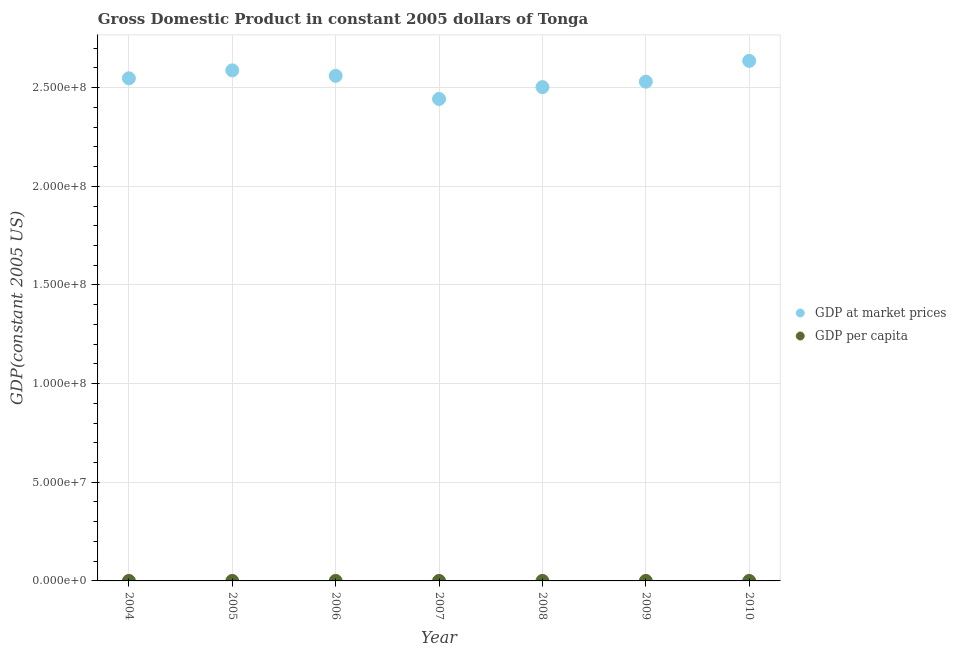Is the number of dotlines equal to the number of legend labels?
Offer a terse response. Yes. What is the gdp at market prices in 2006?
Give a very brief answer. 2.56e+08. Across all years, what is the maximum gdp at market prices?
Give a very brief answer. 2.64e+08. Across all years, what is the minimum gdp per capita?
Keep it short and to the point. 2390.7. In which year was the gdp per capita minimum?
Keep it short and to the point. 2007. What is the total gdp at market prices in the graph?
Your answer should be compact. 1.78e+09. What is the difference between the gdp at market prices in 2006 and that in 2008?
Your answer should be compact. 5.70e+06. What is the difference between the gdp per capita in 2010 and the gdp at market prices in 2004?
Offer a terse response. -2.55e+08. What is the average gdp at market prices per year?
Ensure brevity in your answer.  2.54e+08. In the year 2010, what is the difference between the gdp at market prices and gdp per capita?
Ensure brevity in your answer.  2.64e+08. In how many years, is the gdp per capita greater than 10000000 US$?
Your response must be concise. 0. What is the ratio of the gdp at market prices in 2006 to that in 2007?
Your response must be concise. 1.05. Is the difference between the gdp at market prices in 2005 and 2009 greater than the difference between the gdp per capita in 2005 and 2009?
Offer a very short reply. Yes. What is the difference between the highest and the second highest gdp per capita?
Provide a succinct answer. 23.91. What is the difference between the highest and the lowest gdp at market prices?
Provide a succinct answer. 1.93e+07. Is the gdp per capita strictly less than the gdp at market prices over the years?
Give a very brief answer. Yes. How many dotlines are there?
Ensure brevity in your answer.  2. How many years are there in the graph?
Ensure brevity in your answer.  7. What is the difference between two consecutive major ticks on the Y-axis?
Provide a succinct answer. 5.00e+07. Does the graph contain grids?
Your answer should be compact. Yes. Where does the legend appear in the graph?
Give a very brief answer. Center right. How are the legend labels stacked?
Offer a very short reply. Vertical. What is the title of the graph?
Make the answer very short. Gross Domestic Product in constant 2005 dollars of Tonga. What is the label or title of the X-axis?
Offer a terse response. Year. What is the label or title of the Y-axis?
Offer a terse response. GDP(constant 2005 US). What is the GDP(constant 2005 US) of GDP at market prices in 2004?
Provide a short and direct response. 2.55e+08. What is the GDP(constant 2005 US) in GDP per capita in 2004?
Make the answer very short. 2541.48. What is the GDP(constant 2005 US) in GDP at market prices in 2005?
Make the answer very short. 2.59e+08. What is the GDP(constant 2005 US) of GDP per capita in 2005?
Your response must be concise. 2565.39. What is the GDP(constant 2005 US) in GDP at market prices in 2006?
Offer a terse response. 2.56e+08. What is the GDP(constant 2005 US) in GDP per capita in 2006?
Your answer should be very brief. 2521.56. What is the GDP(constant 2005 US) in GDP at market prices in 2007?
Make the answer very short. 2.44e+08. What is the GDP(constant 2005 US) in GDP per capita in 2007?
Keep it short and to the point. 2390.7. What is the GDP(constant 2005 US) of GDP at market prices in 2008?
Give a very brief answer. 2.50e+08. What is the GDP(constant 2005 US) in GDP per capita in 2008?
Your response must be concise. 2434.01. What is the GDP(constant 2005 US) in GDP at market prices in 2009?
Keep it short and to the point. 2.53e+08. What is the GDP(constant 2005 US) of GDP per capita in 2009?
Ensure brevity in your answer.  2446.5. What is the GDP(constant 2005 US) in GDP at market prices in 2010?
Make the answer very short. 2.64e+08. What is the GDP(constant 2005 US) in GDP per capita in 2010?
Your answer should be compact. 2535.39. Across all years, what is the maximum GDP(constant 2005 US) in GDP at market prices?
Your answer should be very brief. 2.64e+08. Across all years, what is the maximum GDP(constant 2005 US) in GDP per capita?
Offer a terse response. 2565.39. Across all years, what is the minimum GDP(constant 2005 US) of GDP at market prices?
Ensure brevity in your answer.  2.44e+08. Across all years, what is the minimum GDP(constant 2005 US) of GDP per capita?
Offer a terse response. 2390.7. What is the total GDP(constant 2005 US) of GDP at market prices in the graph?
Your response must be concise. 1.78e+09. What is the total GDP(constant 2005 US) in GDP per capita in the graph?
Offer a very short reply. 1.74e+04. What is the difference between the GDP(constant 2005 US) in GDP at market prices in 2004 and that in 2005?
Make the answer very short. -4.02e+06. What is the difference between the GDP(constant 2005 US) of GDP per capita in 2004 and that in 2005?
Make the answer very short. -23.91. What is the difference between the GDP(constant 2005 US) in GDP at market prices in 2004 and that in 2006?
Your answer should be compact. -1.23e+06. What is the difference between the GDP(constant 2005 US) of GDP per capita in 2004 and that in 2006?
Your answer should be very brief. 19.92. What is the difference between the GDP(constant 2005 US) of GDP at market prices in 2004 and that in 2007?
Your answer should be compact. 1.05e+07. What is the difference between the GDP(constant 2005 US) of GDP per capita in 2004 and that in 2007?
Your response must be concise. 150.78. What is the difference between the GDP(constant 2005 US) in GDP at market prices in 2004 and that in 2008?
Offer a very short reply. 4.47e+06. What is the difference between the GDP(constant 2005 US) in GDP per capita in 2004 and that in 2008?
Ensure brevity in your answer.  107.47. What is the difference between the GDP(constant 2005 US) in GDP at market prices in 2004 and that in 2009?
Offer a very short reply. 1.72e+06. What is the difference between the GDP(constant 2005 US) of GDP per capita in 2004 and that in 2009?
Give a very brief answer. 94.98. What is the difference between the GDP(constant 2005 US) of GDP at market prices in 2004 and that in 2010?
Offer a terse response. -8.82e+06. What is the difference between the GDP(constant 2005 US) of GDP per capita in 2004 and that in 2010?
Your response must be concise. 6.09. What is the difference between the GDP(constant 2005 US) of GDP at market prices in 2005 and that in 2006?
Provide a succinct answer. 2.78e+06. What is the difference between the GDP(constant 2005 US) of GDP per capita in 2005 and that in 2006?
Provide a succinct answer. 43.83. What is the difference between the GDP(constant 2005 US) in GDP at market prices in 2005 and that in 2007?
Make the answer very short. 1.45e+07. What is the difference between the GDP(constant 2005 US) in GDP per capita in 2005 and that in 2007?
Keep it short and to the point. 174.68. What is the difference between the GDP(constant 2005 US) in GDP at market prices in 2005 and that in 2008?
Your answer should be very brief. 8.48e+06. What is the difference between the GDP(constant 2005 US) in GDP per capita in 2005 and that in 2008?
Keep it short and to the point. 131.38. What is the difference between the GDP(constant 2005 US) of GDP at market prices in 2005 and that in 2009?
Offer a very short reply. 5.73e+06. What is the difference between the GDP(constant 2005 US) in GDP per capita in 2005 and that in 2009?
Offer a very short reply. 118.89. What is the difference between the GDP(constant 2005 US) of GDP at market prices in 2005 and that in 2010?
Your answer should be very brief. -4.81e+06. What is the difference between the GDP(constant 2005 US) in GDP per capita in 2005 and that in 2010?
Provide a short and direct response. 29.99. What is the difference between the GDP(constant 2005 US) of GDP at market prices in 2006 and that in 2007?
Your answer should be very brief. 1.17e+07. What is the difference between the GDP(constant 2005 US) in GDP per capita in 2006 and that in 2007?
Offer a terse response. 130.85. What is the difference between the GDP(constant 2005 US) of GDP at market prices in 2006 and that in 2008?
Keep it short and to the point. 5.70e+06. What is the difference between the GDP(constant 2005 US) in GDP per capita in 2006 and that in 2008?
Keep it short and to the point. 87.55. What is the difference between the GDP(constant 2005 US) of GDP at market prices in 2006 and that in 2009?
Make the answer very short. 2.95e+06. What is the difference between the GDP(constant 2005 US) in GDP per capita in 2006 and that in 2009?
Ensure brevity in your answer.  75.06. What is the difference between the GDP(constant 2005 US) of GDP at market prices in 2006 and that in 2010?
Ensure brevity in your answer.  -7.59e+06. What is the difference between the GDP(constant 2005 US) of GDP per capita in 2006 and that in 2010?
Give a very brief answer. -13.84. What is the difference between the GDP(constant 2005 US) of GDP at market prices in 2007 and that in 2008?
Offer a very short reply. -6.00e+06. What is the difference between the GDP(constant 2005 US) in GDP per capita in 2007 and that in 2008?
Provide a short and direct response. -43.31. What is the difference between the GDP(constant 2005 US) in GDP at market prices in 2007 and that in 2009?
Give a very brief answer. -8.75e+06. What is the difference between the GDP(constant 2005 US) of GDP per capita in 2007 and that in 2009?
Provide a succinct answer. -55.79. What is the difference between the GDP(constant 2005 US) in GDP at market prices in 2007 and that in 2010?
Provide a short and direct response. -1.93e+07. What is the difference between the GDP(constant 2005 US) in GDP per capita in 2007 and that in 2010?
Make the answer very short. -144.69. What is the difference between the GDP(constant 2005 US) in GDP at market prices in 2008 and that in 2009?
Your response must be concise. -2.75e+06. What is the difference between the GDP(constant 2005 US) in GDP per capita in 2008 and that in 2009?
Your answer should be very brief. -12.49. What is the difference between the GDP(constant 2005 US) in GDP at market prices in 2008 and that in 2010?
Offer a terse response. -1.33e+07. What is the difference between the GDP(constant 2005 US) of GDP per capita in 2008 and that in 2010?
Your answer should be very brief. -101.38. What is the difference between the GDP(constant 2005 US) in GDP at market prices in 2009 and that in 2010?
Your response must be concise. -1.05e+07. What is the difference between the GDP(constant 2005 US) in GDP per capita in 2009 and that in 2010?
Offer a terse response. -88.9. What is the difference between the GDP(constant 2005 US) in GDP at market prices in 2004 and the GDP(constant 2005 US) in GDP per capita in 2005?
Offer a terse response. 2.55e+08. What is the difference between the GDP(constant 2005 US) in GDP at market prices in 2004 and the GDP(constant 2005 US) in GDP per capita in 2006?
Your answer should be compact. 2.55e+08. What is the difference between the GDP(constant 2005 US) in GDP at market prices in 2004 and the GDP(constant 2005 US) in GDP per capita in 2007?
Provide a succinct answer. 2.55e+08. What is the difference between the GDP(constant 2005 US) in GDP at market prices in 2004 and the GDP(constant 2005 US) in GDP per capita in 2008?
Your response must be concise. 2.55e+08. What is the difference between the GDP(constant 2005 US) of GDP at market prices in 2004 and the GDP(constant 2005 US) of GDP per capita in 2009?
Offer a terse response. 2.55e+08. What is the difference between the GDP(constant 2005 US) in GDP at market prices in 2004 and the GDP(constant 2005 US) in GDP per capita in 2010?
Your answer should be compact. 2.55e+08. What is the difference between the GDP(constant 2005 US) of GDP at market prices in 2005 and the GDP(constant 2005 US) of GDP per capita in 2006?
Your answer should be very brief. 2.59e+08. What is the difference between the GDP(constant 2005 US) of GDP at market prices in 2005 and the GDP(constant 2005 US) of GDP per capita in 2007?
Offer a very short reply. 2.59e+08. What is the difference between the GDP(constant 2005 US) in GDP at market prices in 2005 and the GDP(constant 2005 US) in GDP per capita in 2008?
Make the answer very short. 2.59e+08. What is the difference between the GDP(constant 2005 US) of GDP at market prices in 2005 and the GDP(constant 2005 US) of GDP per capita in 2009?
Offer a very short reply. 2.59e+08. What is the difference between the GDP(constant 2005 US) of GDP at market prices in 2005 and the GDP(constant 2005 US) of GDP per capita in 2010?
Ensure brevity in your answer.  2.59e+08. What is the difference between the GDP(constant 2005 US) of GDP at market prices in 2006 and the GDP(constant 2005 US) of GDP per capita in 2007?
Ensure brevity in your answer.  2.56e+08. What is the difference between the GDP(constant 2005 US) of GDP at market prices in 2006 and the GDP(constant 2005 US) of GDP per capita in 2008?
Make the answer very short. 2.56e+08. What is the difference between the GDP(constant 2005 US) of GDP at market prices in 2006 and the GDP(constant 2005 US) of GDP per capita in 2009?
Provide a short and direct response. 2.56e+08. What is the difference between the GDP(constant 2005 US) of GDP at market prices in 2006 and the GDP(constant 2005 US) of GDP per capita in 2010?
Your answer should be very brief. 2.56e+08. What is the difference between the GDP(constant 2005 US) of GDP at market prices in 2007 and the GDP(constant 2005 US) of GDP per capita in 2008?
Your answer should be very brief. 2.44e+08. What is the difference between the GDP(constant 2005 US) in GDP at market prices in 2007 and the GDP(constant 2005 US) in GDP per capita in 2009?
Your answer should be very brief. 2.44e+08. What is the difference between the GDP(constant 2005 US) of GDP at market prices in 2007 and the GDP(constant 2005 US) of GDP per capita in 2010?
Provide a short and direct response. 2.44e+08. What is the difference between the GDP(constant 2005 US) in GDP at market prices in 2008 and the GDP(constant 2005 US) in GDP per capita in 2009?
Your response must be concise. 2.50e+08. What is the difference between the GDP(constant 2005 US) in GDP at market prices in 2008 and the GDP(constant 2005 US) in GDP per capita in 2010?
Your response must be concise. 2.50e+08. What is the difference between the GDP(constant 2005 US) of GDP at market prices in 2009 and the GDP(constant 2005 US) of GDP per capita in 2010?
Your answer should be compact. 2.53e+08. What is the average GDP(constant 2005 US) of GDP at market prices per year?
Your answer should be compact. 2.54e+08. What is the average GDP(constant 2005 US) of GDP per capita per year?
Provide a succinct answer. 2490.72. In the year 2004, what is the difference between the GDP(constant 2005 US) of GDP at market prices and GDP(constant 2005 US) of GDP per capita?
Offer a very short reply. 2.55e+08. In the year 2005, what is the difference between the GDP(constant 2005 US) in GDP at market prices and GDP(constant 2005 US) in GDP per capita?
Your answer should be very brief. 2.59e+08. In the year 2006, what is the difference between the GDP(constant 2005 US) in GDP at market prices and GDP(constant 2005 US) in GDP per capita?
Make the answer very short. 2.56e+08. In the year 2007, what is the difference between the GDP(constant 2005 US) in GDP at market prices and GDP(constant 2005 US) in GDP per capita?
Your answer should be very brief. 2.44e+08. In the year 2008, what is the difference between the GDP(constant 2005 US) in GDP at market prices and GDP(constant 2005 US) in GDP per capita?
Provide a succinct answer. 2.50e+08. In the year 2009, what is the difference between the GDP(constant 2005 US) in GDP at market prices and GDP(constant 2005 US) in GDP per capita?
Provide a short and direct response. 2.53e+08. In the year 2010, what is the difference between the GDP(constant 2005 US) of GDP at market prices and GDP(constant 2005 US) of GDP per capita?
Offer a terse response. 2.64e+08. What is the ratio of the GDP(constant 2005 US) of GDP at market prices in 2004 to that in 2005?
Keep it short and to the point. 0.98. What is the ratio of the GDP(constant 2005 US) of GDP per capita in 2004 to that in 2005?
Offer a terse response. 0.99. What is the ratio of the GDP(constant 2005 US) of GDP per capita in 2004 to that in 2006?
Offer a very short reply. 1.01. What is the ratio of the GDP(constant 2005 US) in GDP at market prices in 2004 to that in 2007?
Provide a succinct answer. 1.04. What is the ratio of the GDP(constant 2005 US) of GDP per capita in 2004 to that in 2007?
Your answer should be very brief. 1.06. What is the ratio of the GDP(constant 2005 US) in GDP at market prices in 2004 to that in 2008?
Provide a short and direct response. 1.02. What is the ratio of the GDP(constant 2005 US) in GDP per capita in 2004 to that in 2008?
Your response must be concise. 1.04. What is the ratio of the GDP(constant 2005 US) of GDP at market prices in 2004 to that in 2009?
Ensure brevity in your answer.  1.01. What is the ratio of the GDP(constant 2005 US) of GDP per capita in 2004 to that in 2009?
Your answer should be compact. 1.04. What is the ratio of the GDP(constant 2005 US) in GDP at market prices in 2004 to that in 2010?
Your answer should be very brief. 0.97. What is the ratio of the GDP(constant 2005 US) in GDP per capita in 2004 to that in 2010?
Your answer should be compact. 1. What is the ratio of the GDP(constant 2005 US) in GDP at market prices in 2005 to that in 2006?
Ensure brevity in your answer.  1.01. What is the ratio of the GDP(constant 2005 US) in GDP per capita in 2005 to that in 2006?
Your answer should be very brief. 1.02. What is the ratio of the GDP(constant 2005 US) of GDP at market prices in 2005 to that in 2007?
Ensure brevity in your answer.  1.06. What is the ratio of the GDP(constant 2005 US) in GDP per capita in 2005 to that in 2007?
Make the answer very short. 1.07. What is the ratio of the GDP(constant 2005 US) in GDP at market prices in 2005 to that in 2008?
Ensure brevity in your answer.  1.03. What is the ratio of the GDP(constant 2005 US) of GDP per capita in 2005 to that in 2008?
Your response must be concise. 1.05. What is the ratio of the GDP(constant 2005 US) of GDP at market prices in 2005 to that in 2009?
Provide a succinct answer. 1.02. What is the ratio of the GDP(constant 2005 US) of GDP per capita in 2005 to that in 2009?
Offer a very short reply. 1.05. What is the ratio of the GDP(constant 2005 US) in GDP at market prices in 2005 to that in 2010?
Your answer should be compact. 0.98. What is the ratio of the GDP(constant 2005 US) in GDP per capita in 2005 to that in 2010?
Your answer should be very brief. 1.01. What is the ratio of the GDP(constant 2005 US) in GDP at market prices in 2006 to that in 2007?
Your response must be concise. 1.05. What is the ratio of the GDP(constant 2005 US) in GDP per capita in 2006 to that in 2007?
Provide a short and direct response. 1.05. What is the ratio of the GDP(constant 2005 US) of GDP at market prices in 2006 to that in 2008?
Provide a succinct answer. 1.02. What is the ratio of the GDP(constant 2005 US) of GDP per capita in 2006 to that in 2008?
Provide a short and direct response. 1.04. What is the ratio of the GDP(constant 2005 US) of GDP at market prices in 2006 to that in 2009?
Your answer should be very brief. 1.01. What is the ratio of the GDP(constant 2005 US) of GDP per capita in 2006 to that in 2009?
Offer a very short reply. 1.03. What is the ratio of the GDP(constant 2005 US) in GDP at market prices in 2006 to that in 2010?
Ensure brevity in your answer.  0.97. What is the ratio of the GDP(constant 2005 US) in GDP per capita in 2007 to that in 2008?
Make the answer very short. 0.98. What is the ratio of the GDP(constant 2005 US) in GDP at market prices in 2007 to that in 2009?
Your response must be concise. 0.97. What is the ratio of the GDP(constant 2005 US) of GDP per capita in 2007 to that in 2009?
Make the answer very short. 0.98. What is the ratio of the GDP(constant 2005 US) in GDP at market prices in 2007 to that in 2010?
Give a very brief answer. 0.93. What is the ratio of the GDP(constant 2005 US) in GDP per capita in 2007 to that in 2010?
Your answer should be compact. 0.94. What is the ratio of the GDP(constant 2005 US) of GDP at market prices in 2008 to that in 2009?
Keep it short and to the point. 0.99. What is the ratio of the GDP(constant 2005 US) in GDP at market prices in 2008 to that in 2010?
Offer a terse response. 0.95. What is the ratio of the GDP(constant 2005 US) of GDP per capita in 2009 to that in 2010?
Your response must be concise. 0.96. What is the difference between the highest and the second highest GDP(constant 2005 US) of GDP at market prices?
Offer a terse response. 4.81e+06. What is the difference between the highest and the second highest GDP(constant 2005 US) in GDP per capita?
Your response must be concise. 23.91. What is the difference between the highest and the lowest GDP(constant 2005 US) in GDP at market prices?
Offer a very short reply. 1.93e+07. What is the difference between the highest and the lowest GDP(constant 2005 US) in GDP per capita?
Give a very brief answer. 174.68. 